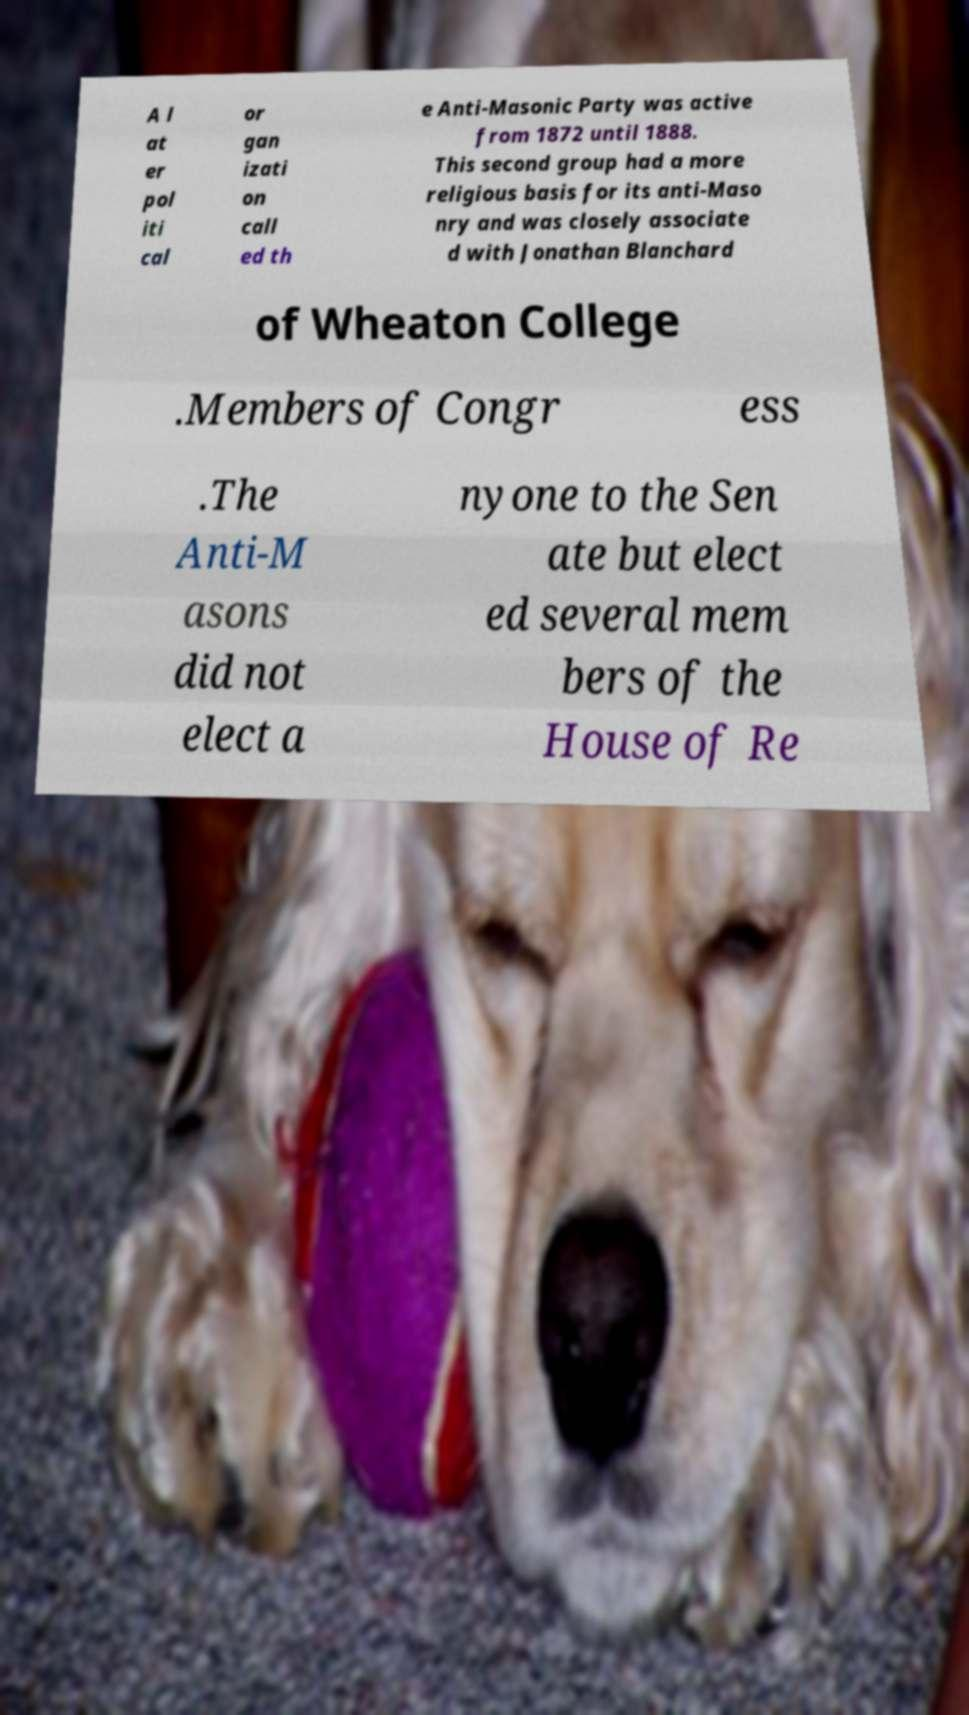Can you read and provide the text displayed in the image?This photo seems to have some interesting text. Can you extract and type it out for me? A l at er pol iti cal or gan izati on call ed th e Anti-Masonic Party was active from 1872 until 1888. This second group had a more religious basis for its anti-Maso nry and was closely associate d with Jonathan Blanchard of Wheaton College .Members of Congr ess .The Anti-M asons did not elect a nyone to the Sen ate but elect ed several mem bers of the House of Re 